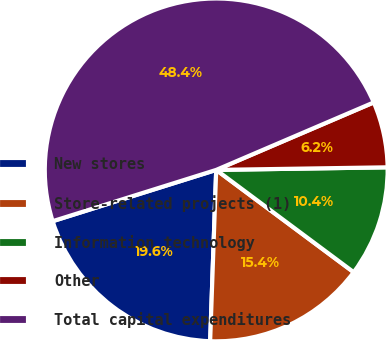Convert chart to OTSL. <chart><loc_0><loc_0><loc_500><loc_500><pie_chart><fcel>New stores<fcel>Store-related projects (1)<fcel>Information technology<fcel>Other<fcel>Total capital expenditures<nl><fcel>19.6%<fcel>15.38%<fcel>10.42%<fcel>6.2%<fcel>48.39%<nl></chart> 